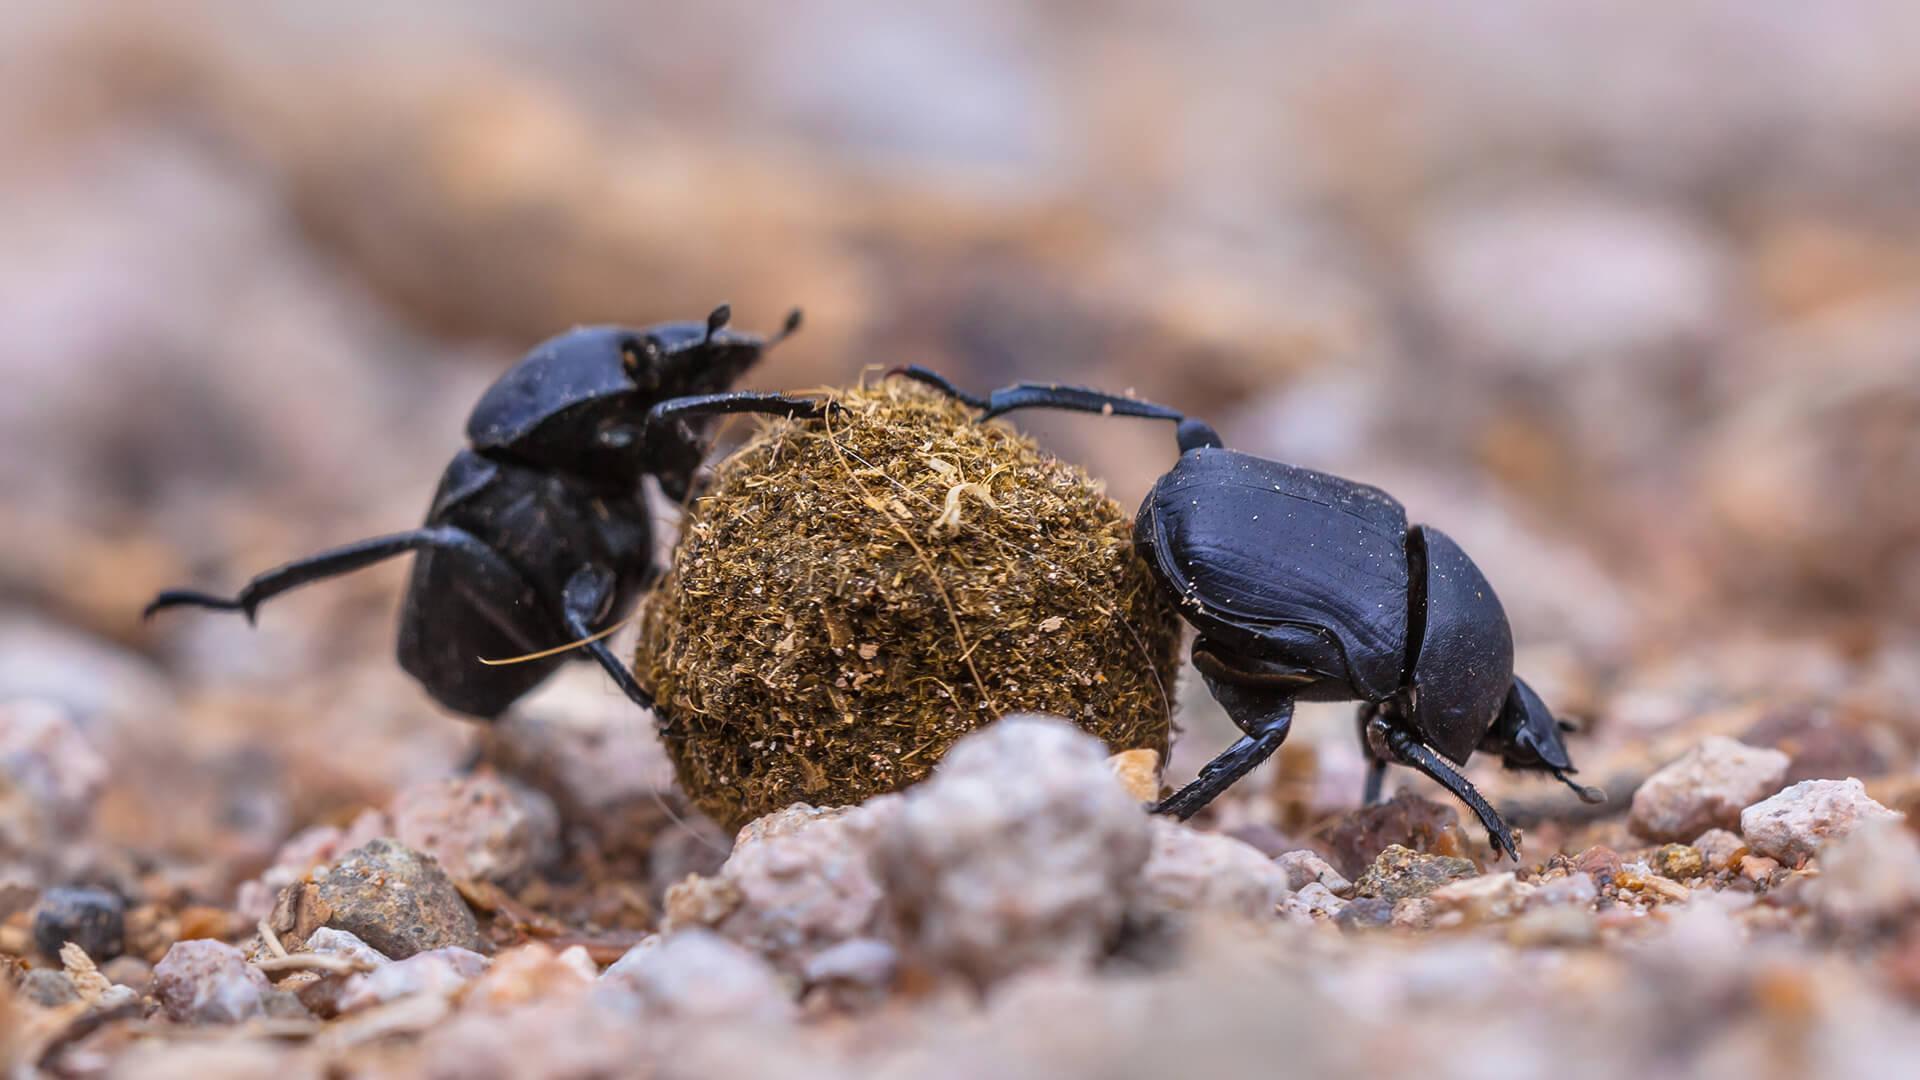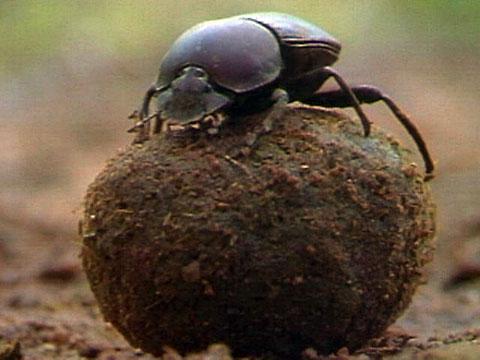The first image is the image on the left, the second image is the image on the right. Examine the images to the left and right. Is the description "There are two dung beetles working on one ball of dung in natural lighting." accurate? Answer yes or no. Yes. The first image is the image on the left, the second image is the image on the right. Given the left and right images, does the statement "One image has more than 20 dung beetles." hold true? Answer yes or no. No. 